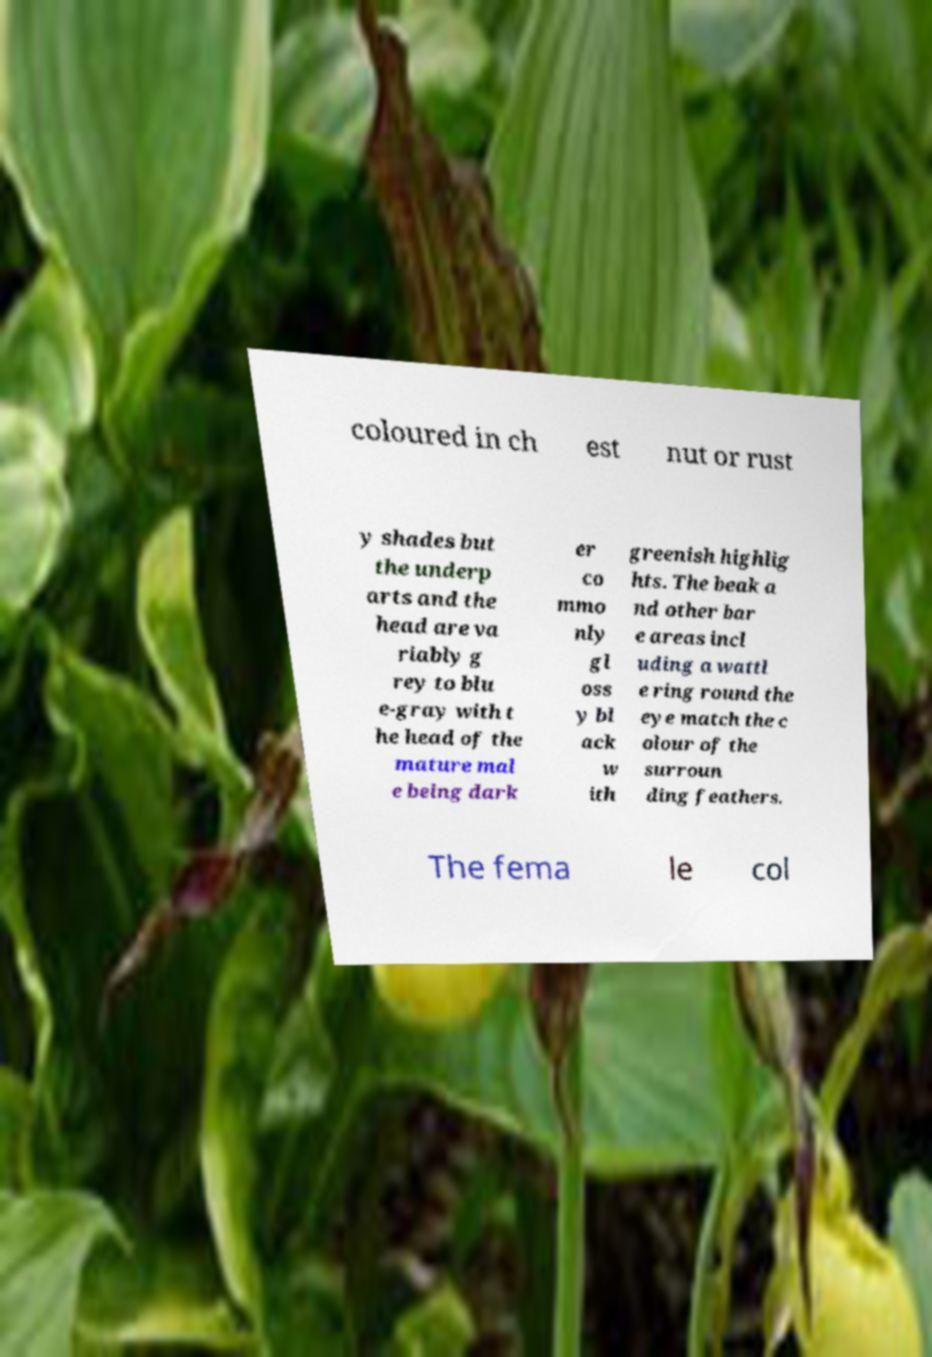There's text embedded in this image that I need extracted. Can you transcribe it verbatim? coloured in ch est nut or rust y shades but the underp arts and the head are va riably g rey to blu e-gray with t he head of the mature mal e being dark er co mmo nly gl oss y bl ack w ith greenish highlig hts. The beak a nd other bar e areas incl uding a wattl e ring round the eye match the c olour of the surroun ding feathers. The fema le col 